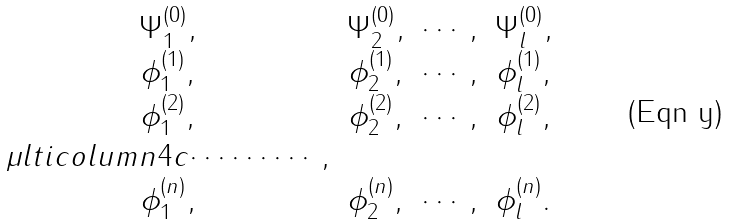Convert formula to latex. <formula><loc_0><loc_0><loc_500><loc_500>\begin{array} { c c c c } \Psi _ { 1 } ^ { ( 0 ) } , & \Psi _ { 2 } ^ { ( 0 ) } , & \cdots , & \Psi _ { l } ^ { ( 0 ) } , \\ \phi _ { 1 } ^ { ( 1 ) } , & \phi _ { 2 } ^ { ( 1 ) } , & \cdots , & \phi _ { l } ^ { ( 1 ) } , \\ \phi _ { 1 } ^ { ( 2 ) } , & \phi _ { 2 } ^ { ( 2 ) } , & \cdots , & \phi _ { l } ^ { ( 2 ) } , \\ \mu l t i c o l u m n { 4 } { c } { \cdots \cdots \cdots , } \\ \phi _ { 1 } ^ { ( n ) } , & \phi _ { 2 } ^ { ( n ) } , & \cdots , & \phi _ { l } ^ { ( n ) } . \end{array}</formula> 